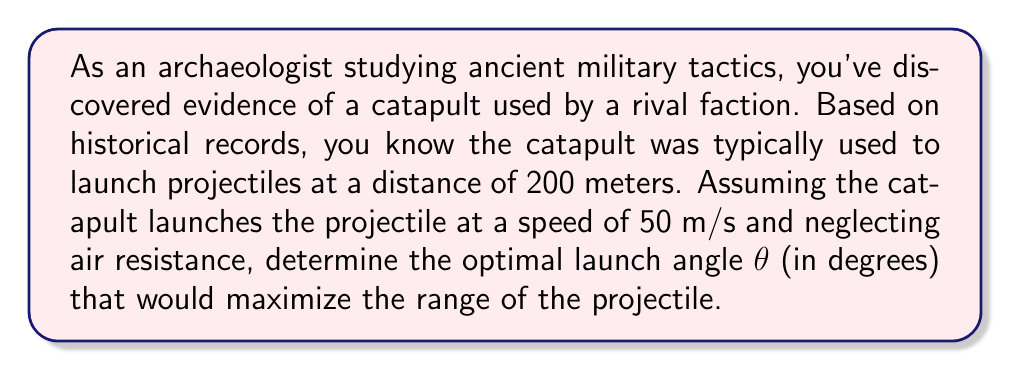What is the answer to this math problem? To solve this problem, we'll use the equation for the range of a projectile and calculus to find the maximum:

1) The range R of a projectile launched at an angle θ with initial velocity v is given by:

   $$R = \frac{v^2 \sin(2θ)}{g}$$

   where g is the acceleration due to gravity (9.8 m/s²).

2) We want to maximize R with respect to θ. To do this, we'll take the derivative of R with respect to θ and set it equal to zero:

   $$\frac{dR}{dθ} = \frac{v^2}{g} \cdot 2\cos(2θ) = 0$$

3) Solving this equation:
   
   $$2\cos(2θ) = 0$$
   $$\cos(2θ) = 0$$

4) The cosine function is zero when its argument is π/2 (or 90°) plus any multiple of π. The smallest positive solution is:

   $$2θ = \frac{π}{2}$$
   $$θ = \frac{π}{4} = 45°$$

5) To confirm this is a maximum (not a minimum), we can check the second derivative:

   $$\frac{d^2R}{dθ^2} = \frac{v^2}{g} \cdot (-4\sin(2θ))$$

   At θ = 45°, this is negative, confirming a maximum.

6) We can verify that this angle gives the maximum range:

   $$R = \frac{50^2 \sin(2 \cdot 45°)}{9.8} = \frac{2500 \cdot 1}{9.8} \approx 255.1 \text{ meters}$$

   This is indeed greater than the typical range of 200 meters mentioned in the question.
Answer: The optimal launch angle θ to maximize the range of the catapult is 45°. 